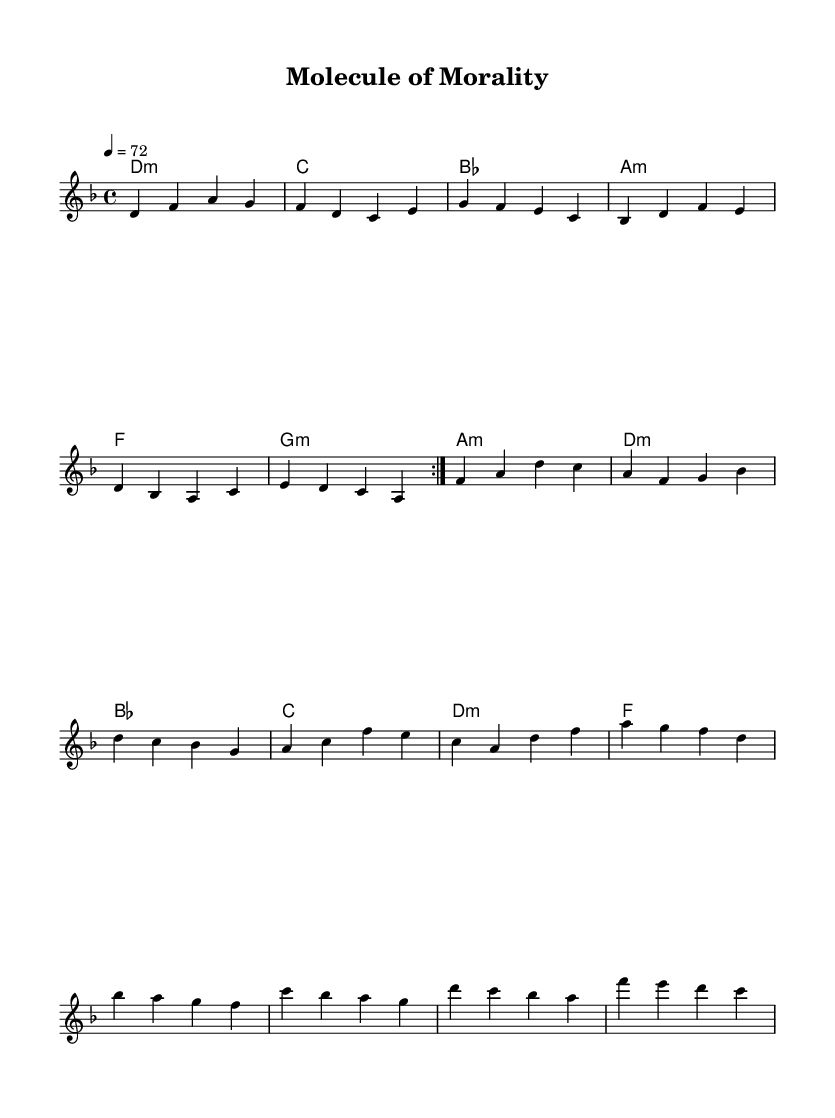What is the key signature of this music? The key signature is indicated at the beginning of the score, showing two flat symbols, which means it is in D minor.
Answer: D minor What is the time signature of this piece? The time signature is located after the key signature, marked as four beats per measure, represented by the "4/4" notation.
Answer: 4/4 What is the tempo marking of this composition? The tempo is marked at the beginning of the score with "4 = 72", indicating that there are 72 beats per minute.
Answer: 72 How many bars are in the melody section? The melody consists of several phrases divided into bars, and by counting them, we find there are a total of 16 bars in this melody section.
Answer: 16 What is the overall theme of the lyrics? The lyrics reflect on ethical considerations and dilemmas related to advancements in biotechnology, emphasizing a moral introspection.
Answer: Ethics in biotech Which chord is used in the first bar? The first bar contains a D minor chord, as indicated by the chord notation in the chord section of the score.
Answer: D minor 